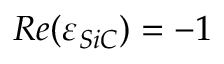<formula> <loc_0><loc_0><loc_500><loc_500>R e ( \varepsilon _ { S i C } ) = - 1</formula> 